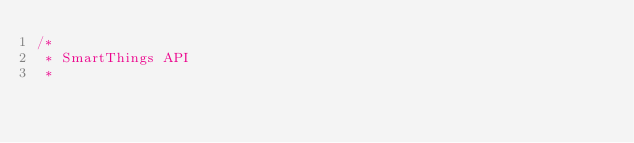<code> <loc_0><loc_0><loc_500><loc_500><_C#_>/* 
 * SmartThings API
 *</code> 